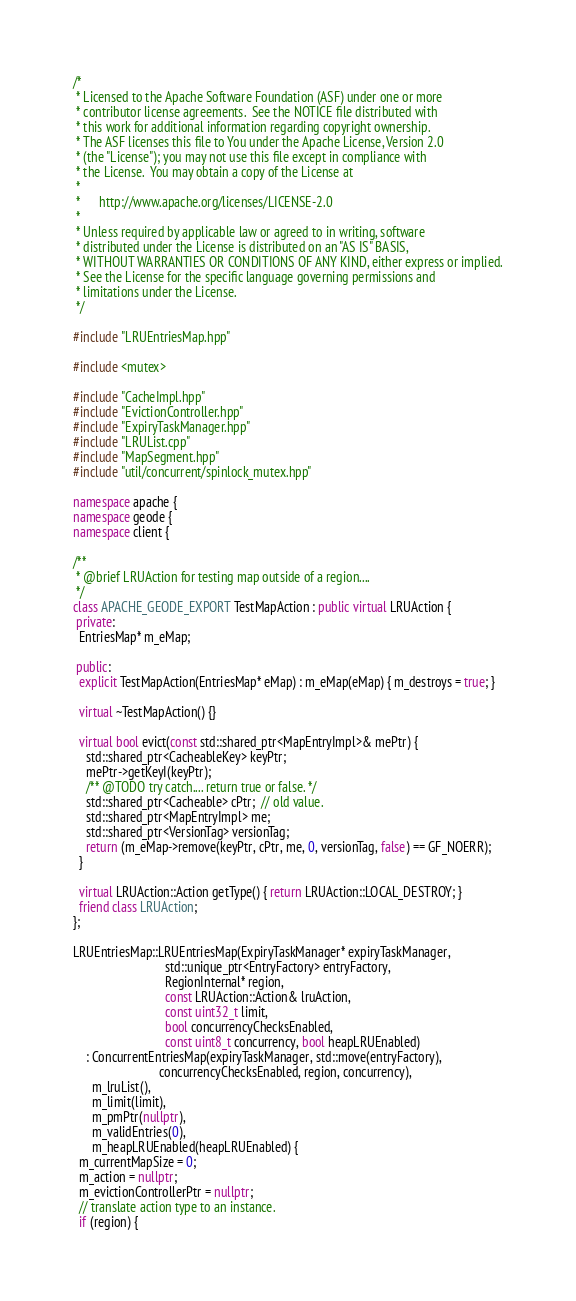<code> <loc_0><loc_0><loc_500><loc_500><_C++_>/*
 * Licensed to the Apache Software Foundation (ASF) under one or more
 * contributor license agreements.  See the NOTICE file distributed with
 * this work for additional information regarding copyright ownership.
 * The ASF licenses this file to You under the Apache License, Version 2.0
 * (the "License"); you may not use this file except in compliance with
 * the License.  You may obtain a copy of the License at
 *
 *      http://www.apache.org/licenses/LICENSE-2.0
 *
 * Unless required by applicable law or agreed to in writing, software
 * distributed under the License is distributed on an "AS IS" BASIS,
 * WITHOUT WARRANTIES OR CONDITIONS OF ANY KIND, either express or implied.
 * See the License for the specific language governing permissions and
 * limitations under the License.
 */

#include "LRUEntriesMap.hpp"

#include <mutex>

#include "CacheImpl.hpp"
#include "EvictionController.hpp"
#include "ExpiryTaskManager.hpp"
#include "LRUList.cpp"
#include "MapSegment.hpp"
#include "util/concurrent/spinlock_mutex.hpp"

namespace apache {
namespace geode {
namespace client {

/**
 * @brief LRUAction for testing map outside of a region....
 */
class APACHE_GEODE_EXPORT TestMapAction : public virtual LRUAction {
 private:
  EntriesMap* m_eMap;

 public:
  explicit TestMapAction(EntriesMap* eMap) : m_eMap(eMap) { m_destroys = true; }

  virtual ~TestMapAction() {}

  virtual bool evict(const std::shared_ptr<MapEntryImpl>& mePtr) {
    std::shared_ptr<CacheableKey> keyPtr;
    mePtr->getKeyI(keyPtr);
    /** @TODO try catch.... return true or false. */
    std::shared_ptr<Cacheable> cPtr;  // old value.
    std::shared_ptr<MapEntryImpl> me;
    std::shared_ptr<VersionTag> versionTag;
    return (m_eMap->remove(keyPtr, cPtr, me, 0, versionTag, false) == GF_NOERR);
  }

  virtual LRUAction::Action getType() { return LRUAction::LOCAL_DESTROY; }
  friend class LRUAction;
};

LRUEntriesMap::LRUEntriesMap(ExpiryTaskManager* expiryTaskManager,
                             std::unique_ptr<EntryFactory> entryFactory,
                             RegionInternal* region,
                             const LRUAction::Action& lruAction,
                             const uint32_t limit,
                             bool concurrencyChecksEnabled,
                             const uint8_t concurrency, bool heapLRUEnabled)
    : ConcurrentEntriesMap(expiryTaskManager, std::move(entryFactory),
                           concurrencyChecksEnabled, region, concurrency),
      m_lruList(),
      m_limit(limit),
      m_pmPtr(nullptr),
      m_validEntries(0),
      m_heapLRUEnabled(heapLRUEnabled) {
  m_currentMapSize = 0;
  m_action = nullptr;
  m_evictionControllerPtr = nullptr;
  // translate action type to an instance.
  if (region) {</code> 